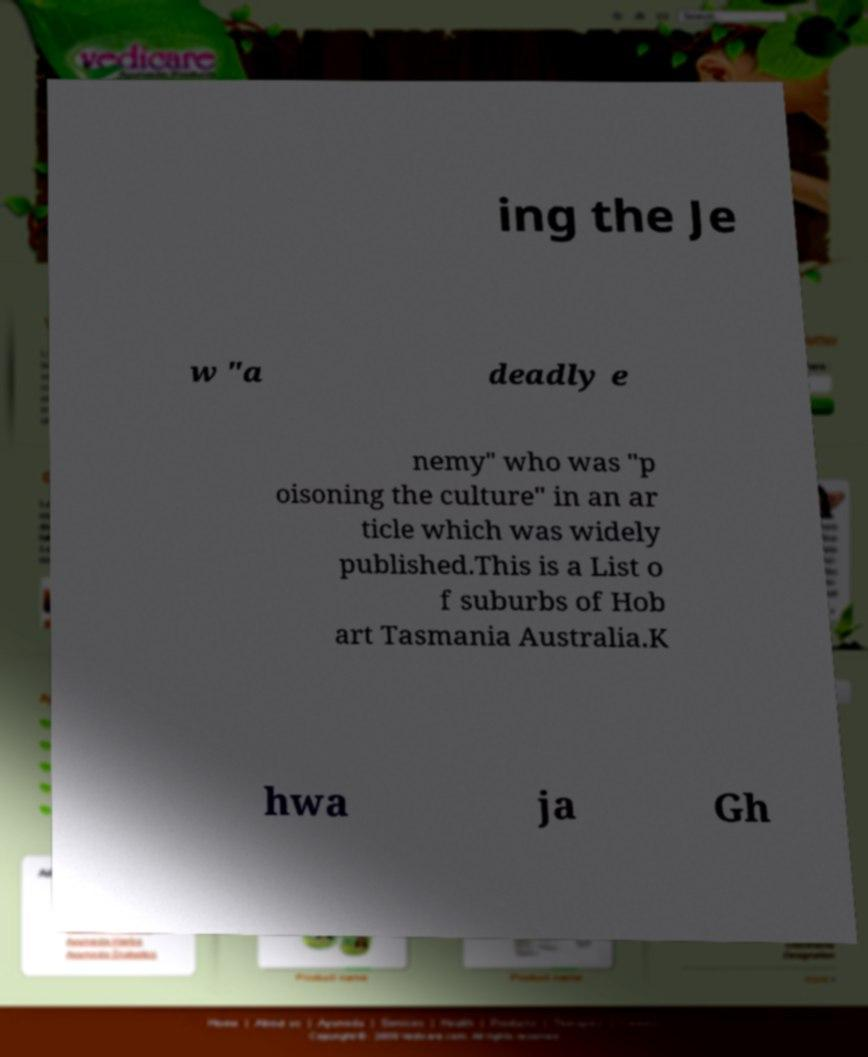For documentation purposes, I need the text within this image transcribed. Could you provide that? ing the Je w "a deadly e nemy" who was "p oisoning the culture" in an ar ticle which was widely published.This is a List o f suburbs of Hob art Tasmania Australia.K hwa ja Gh 